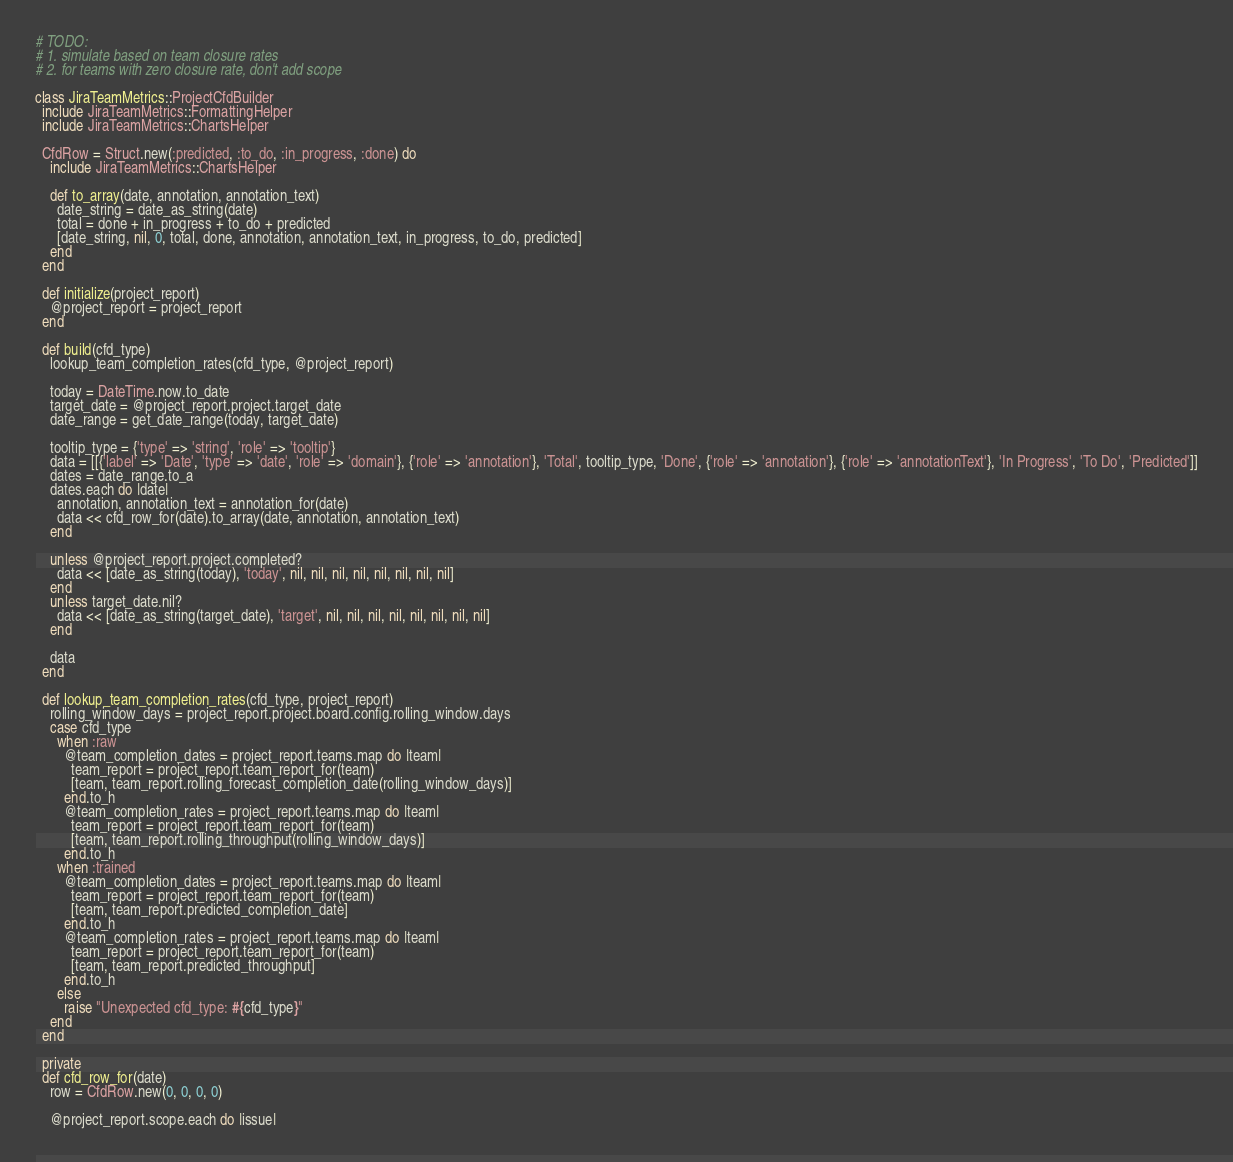Convert code to text. <code><loc_0><loc_0><loc_500><loc_500><_Ruby_># TODO:
# 1. simulate based on team closure rates
# 2. for teams with zero closure rate, don't add scope

class JiraTeamMetrics::ProjectCfdBuilder
  include JiraTeamMetrics::FormattingHelper
  include JiraTeamMetrics::ChartsHelper

  CfdRow = Struct.new(:predicted, :to_do, :in_progress, :done) do
    include JiraTeamMetrics::ChartsHelper

    def to_array(date, annotation, annotation_text)
      date_string = date_as_string(date)
      total = done + in_progress + to_do + predicted
      [date_string, nil, 0, total, done, annotation, annotation_text, in_progress, to_do, predicted]
    end
  end

  def initialize(project_report)
    @project_report = project_report
  end

  def build(cfd_type)
    lookup_team_completion_rates(cfd_type, @project_report)

    today = DateTime.now.to_date
    target_date = @project_report.project.target_date
    date_range = get_date_range(today, target_date)

    tooltip_type = {'type' => 'string', 'role' => 'tooltip'}
    data = [[{'label' => 'Date', 'type' => 'date', 'role' => 'domain'}, {'role' => 'annotation'}, 'Total', tooltip_type, 'Done', {'role' => 'annotation'}, {'role' => 'annotationText'}, 'In Progress', 'To Do', 'Predicted']]
    dates = date_range.to_a
    dates.each do |date|
      annotation, annotation_text = annotation_for(date)
      data << cfd_row_for(date).to_array(date, annotation, annotation_text)
    end

    unless @project_report.project.completed?
      data << [date_as_string(today), 'today', nil, nil, nil, nil, nil, nil, nil, nil]
    end
    unless target_date.nil?
      data << [date_as_string(target_date), 'target', nil, nil, nil, nil, nil, nil, nil, nil]
    end

    data
  end

  def lookup_team_completion_rates(cfd_type, project_report)
    rolling_window_days = project_report.project.board.config.rolling_window.days
    case cfd_type
      when :raw
        @team_completion_dates = project_report.teams.map do |team|
          team_report = project_report.team_report_for(team)
          [team, team_report.rolling_forecast_completion_date(rolling_window_days)]
        end.to_h
        @team_completion_rates = project_report.teams.map do |team|
          team_report = project_report.team_report_for(team)
          [team, team_report.rolling_throughput(rolling_window_days)]
        end.to_h
      when :trained
        @team_completion_dates = project_report.teams.map do |team|
          team_report = project_report.team_report_for(team)
          [team, team_report.predicted_completion_date]
        end.to_h
        @team_completion_rates = project_report.teams.map do |team|
          team_report = project_report.team_report_for(team)
          [team, team_report.predicted_throughput]
        end.to_h
      else
        raise "Unexpected cfd_type: #{cfd_type}"
    end
  end

  private
  def cfd_row_for(date)
    row = CfdRow.new(0, 0, 0, 0)

    @project_report.scope.each do |issue|</code> 